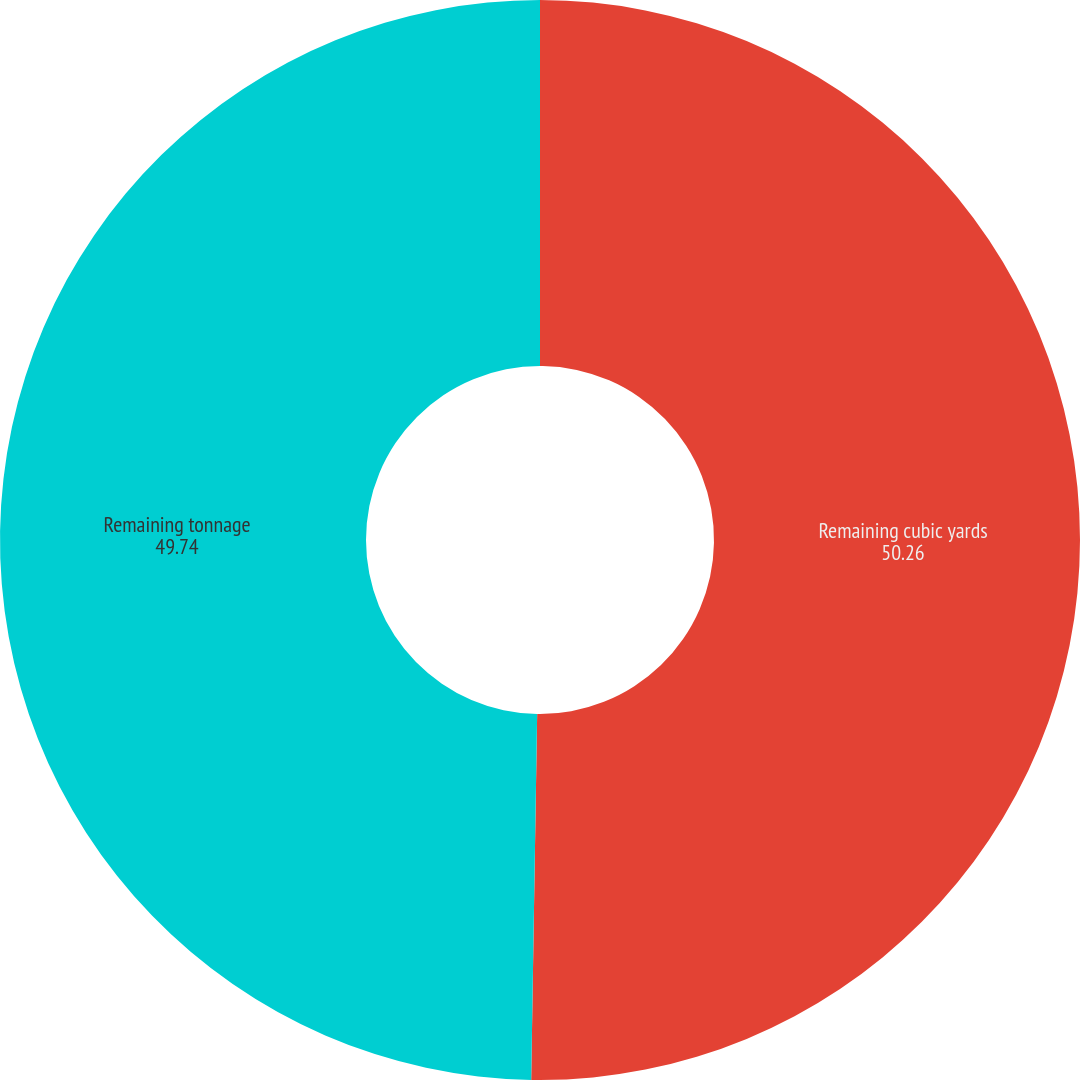Convert chart. <chart><loc_0><loc_0><loc_500><loc_500><pie_chart><fcel>Remaining cubic yards<fcel>Remaining tonnage<nl><fcel>50.26%<fcel>49.74%<nl></chart> 